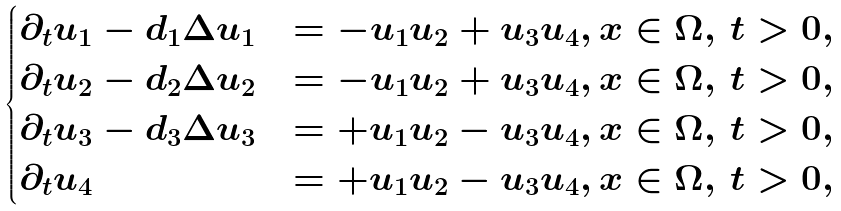Convert formula to latex. <formula><loc_0><loc_0><loc_500><loc_500>\begin{cases} \partial _ { t } u _ { 1 } - d _ { 1 } \Delta u _ { 1 } & = - u _ { 1 } u _ { 2 } + u _ { 3 } u _ { 4 } , x \in \Omega , \, t > 0 , \\ \partial _ { t } u _ { 2 } - d _ { 2 } \Delta u _ { 2 } & = - u _ { 1 } u _ { 2 } + u _ { 3 } u _ { 4 } , x \in \Omega , \, t > 0 , \\ \partial _ { t } u _ { 3 } - d _ { 3 } \Delta u _ { 3 } & = + u _ { 1 } u _ { 2 } - u _ { 3 } u _ { 4 } , x \in \Omega , \, t > 0 , \\ \partial _ { t } u _ { 4 } & = + u _ { 1 } u _ { 2 } - u _ { 3 } u _ { 4 } , x \in \Omega , \, t > 0 , \\ \end{cases}</formula> 